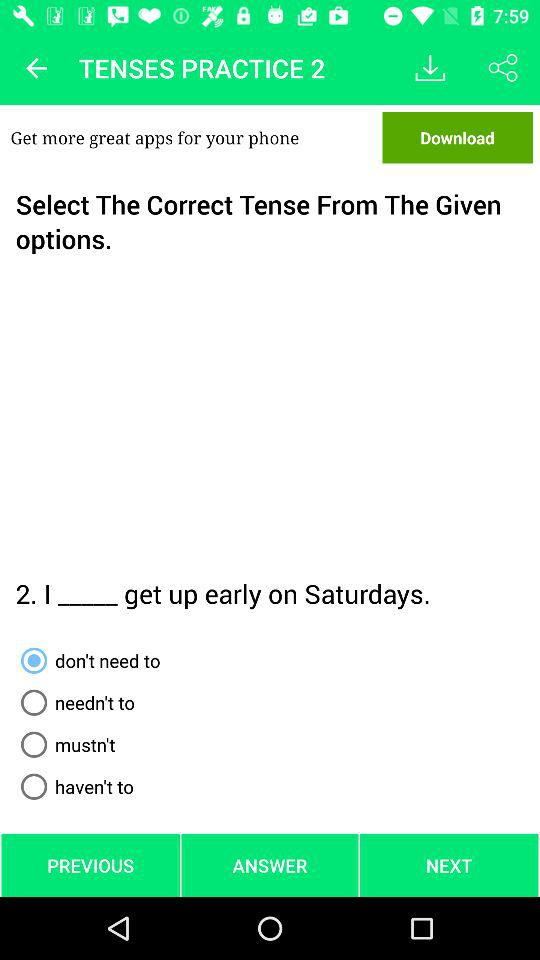Which option has been selected? The selected option is "don't need to". 